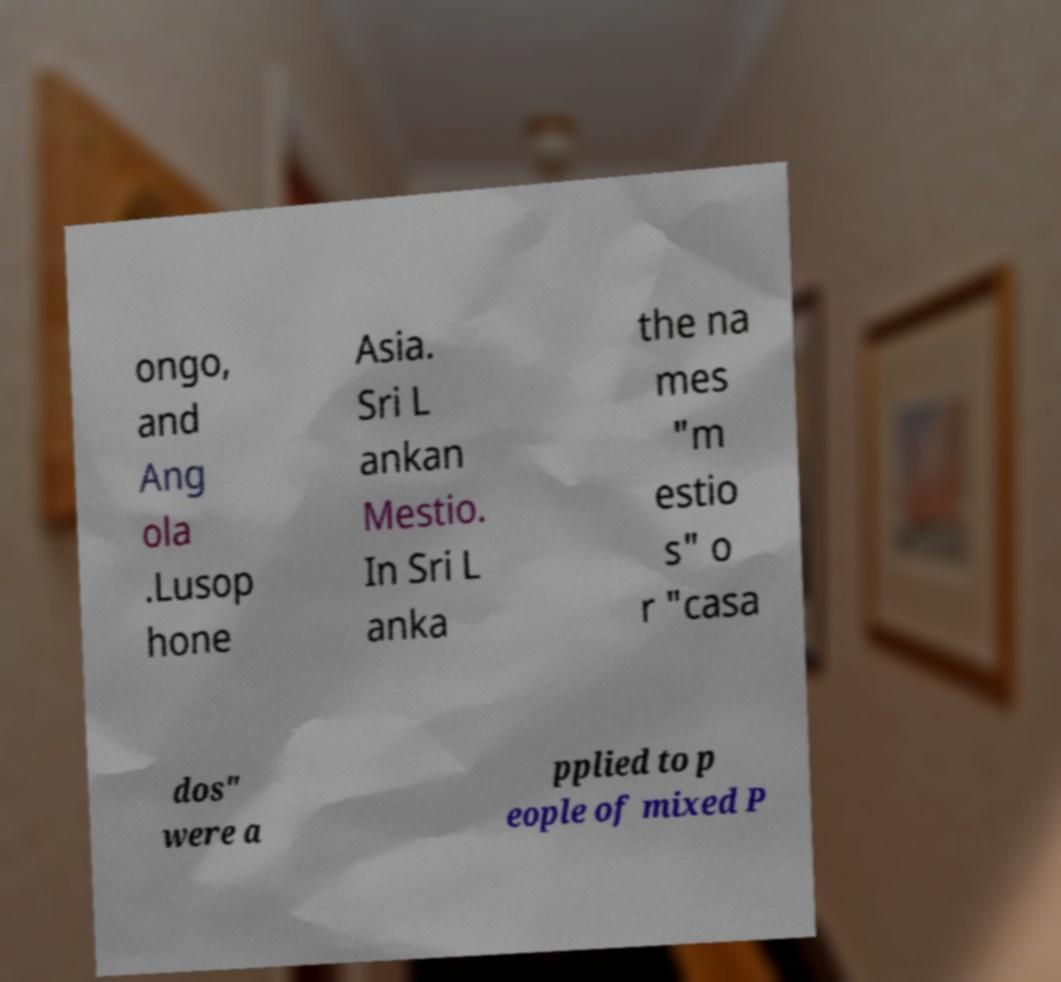I need the written content from this picture converted into text. Can you do that? ongo, and Ang ola .Lusop hone Asia. Sri L ankan Mestio. In Sri L anka the na mes "m estio s" o r "casa dos" were a pplied to p eople of mixed P 